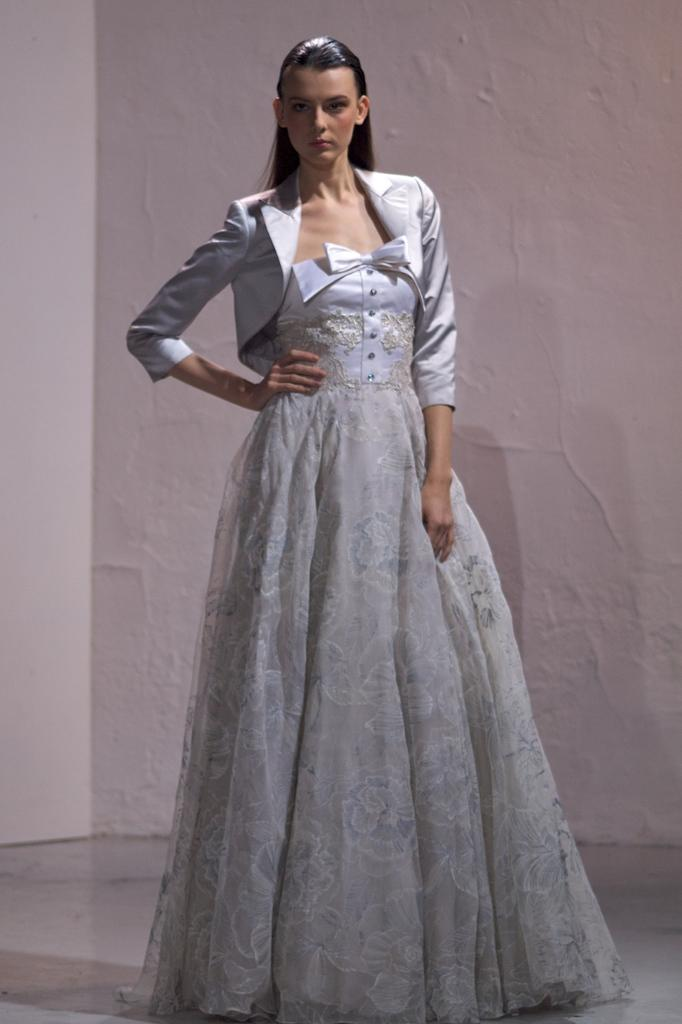What is the main subject of the image? There is a person standing in the image. What is the person wearing? The person is wearing a white dress. What can be seen in the background of the image? The background of the image is white. How many needles are present in the image? There are no needles present in the image. What type of stone can be seen in the person's hand in the image? There is no stone present in the person's hand or anywhere else in the image. 